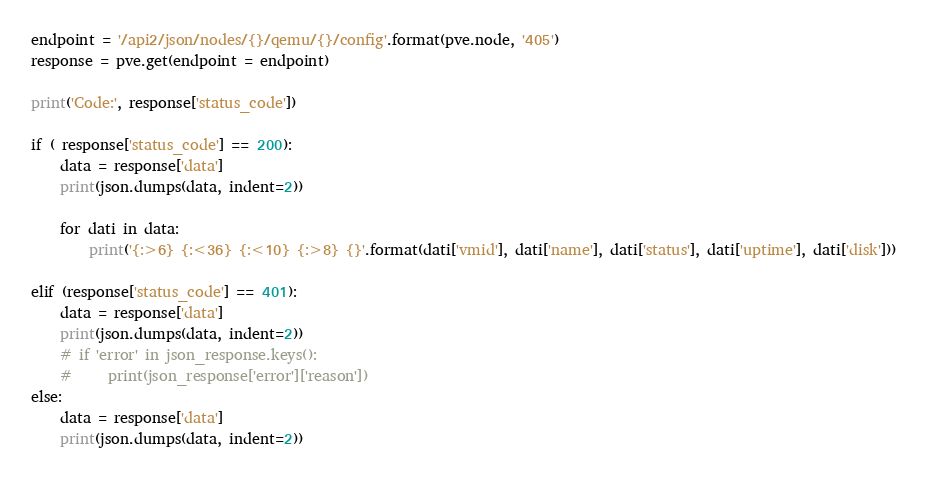Convert code to text. <code><loc_0><loc_0><loc_500><loc_500><_Python_>endpoint = '/api2/json/nodes/{}/qemu/{}/config'.format(pve.node, '405')
response = pve.get(endpoint = endpoint)

print('Code:', response['status_code'])

if ( response['status_code'] == 200):
    data = response['data']
    print(json.dumps(data, indent=2))
    
    for dati in data:
        print('{:>6} {:<36} {:<10} {:>8} {}'.format(dati['vmid'], dati['name'], dati['status'], dati['uptime'], dati['disk']))
                
elif (response['status_code'] == 401):
    data = response['data']
    print(json.dumps(data, indent=2))
    # if 'error' in json_response.keys():
    #     print(json_response['error']['reason'])
else:
    data = response['data']
    print(json.dumps(data, indent=2))</code> 